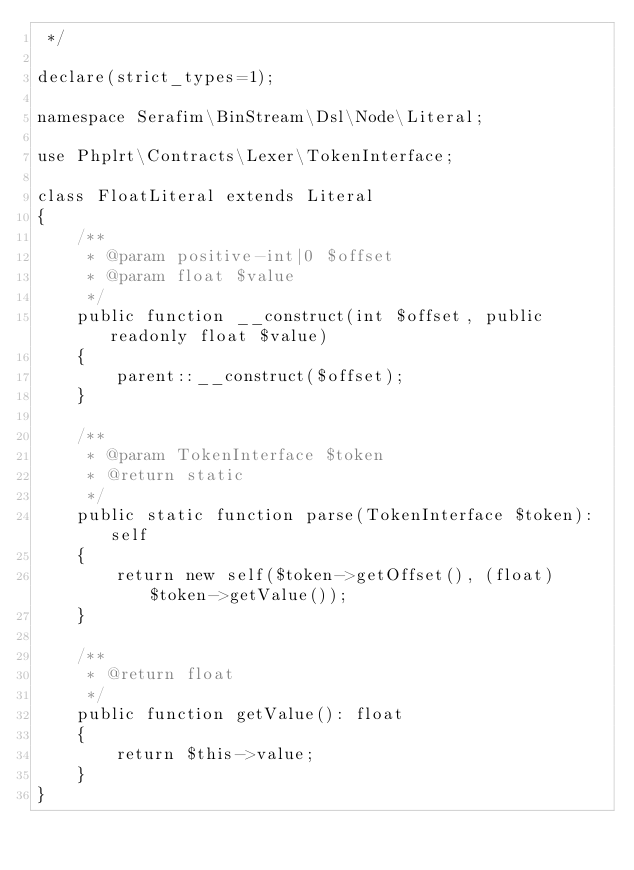Convert code to text. <code><loc_0><loc_0><loc_500><loc_500><_PHP_> */

declare(strict_types=1);

namespace Serafim\BinStream\Dsl\Node\Literal;

use Phplrt\Contracts\Lexer\TokenInterface;

class FloatLiteral extends Literal
{
    /**
     * @param positive-int|0 $offset
     * @param float $value
     */
    public function __construct(int $offset, public readonly float $value)
    {
        parent::__construct($offset);
    }

    /**
     * @param TokenInterface $token
     * @return static
     */
    public static function parse(TokenInterface $token): self
    {
        return new self($token->getOffset(), (float)$token->getValue());
    }

    /**
     * @return float
     */
    public function getValue(): float
    {
        return $this->value;
    }
}
</code> 